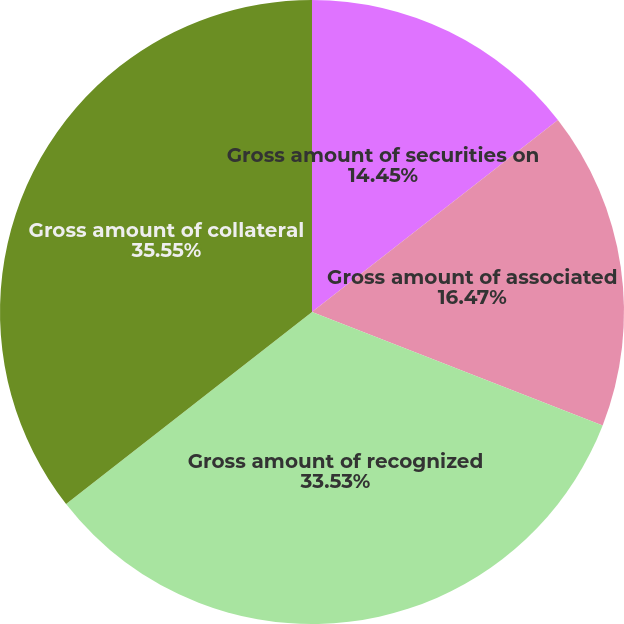<chart> <loc_0><loc_0><loc_500><loc_500><pie_chart><fcel>Gross amount of securities on<fcel>Gross amount of associated<fcel>Gross amount of recognized<fcel>Gross amount of collateral<nl><fcel>14.45%<fcel>16.47%<fcel>33.53%<fcel>35.55%<nl></chart> 